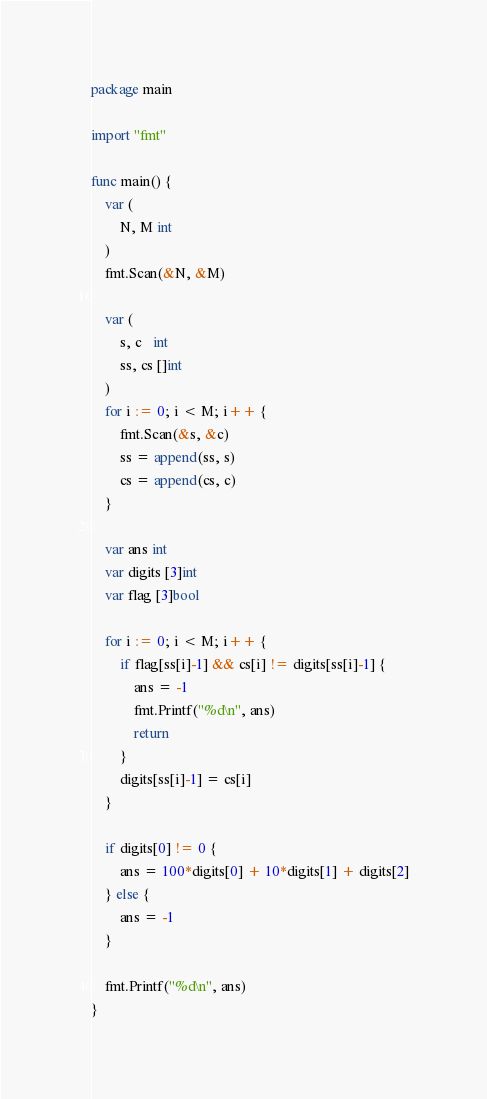<code> <loc_0><loc_0><loc_500><loc_500><_Go_>package main

import "fmt"

func main() {
	var (
		N, M int
	)
	fmt.Scan(&N, &M)

	var (
		s, c   int
		ss, cs []int
	)
	for i := 0; i < M; i++ {
		fmt.Scan(&s, &c)
		ss = append(ss, s)
		cs = append(cs, c)
	}

	var ans int
	var digits [3]int
	var flag [3]bool

	for i := 0; i < M; i++ {
		if flag[ss[i]-1] && cs[i] != digits[ss[i]-1] {
			ans = -1
			fmt.Printf("%d\n", ans)
			return
		}
		digits[ss[i]-1] = cs[i]
	}

	if digits[0] != 0 {
		ans = 100*digits[0] + 10*digits[1] + digits[2]
	} else {
		ans = -1
	}

	fmt.Printf("%d\n", ans)
}
</code> 